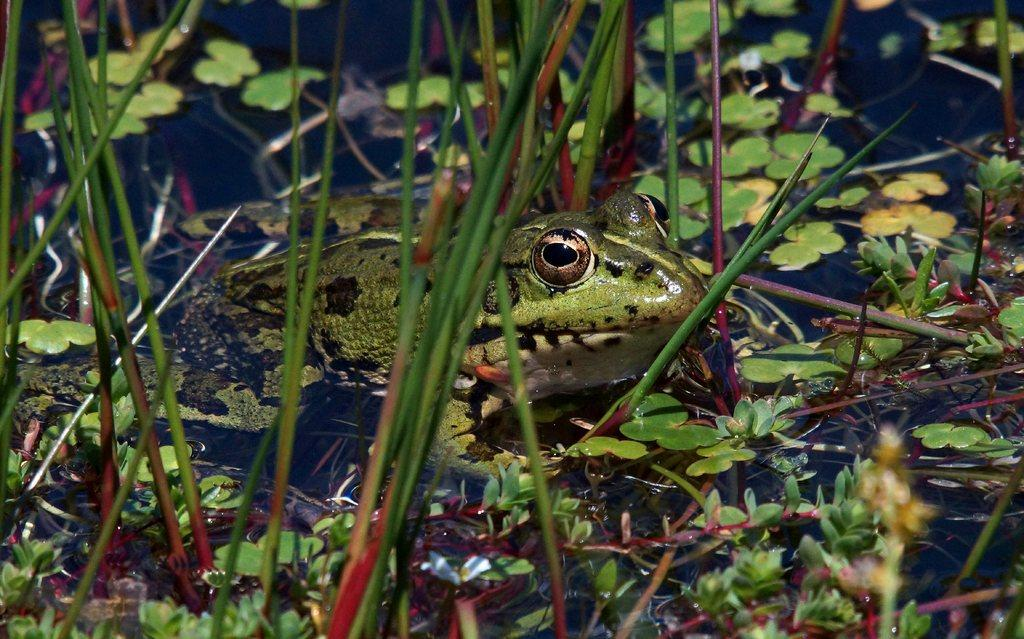What type of animal is in the image? There is a green frog in the image. Where is the frog located? The frog is in the water. What else can be seen in the image besides the frog? There are plants in the image. What shape is the protest taking in the image? There is no protest present in the image, so it is not possible to determine its shape. 